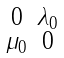Convert formula to latex. <formula><loc_0><loc_0><loc_500><loc_500>\begin{smallmatrix} 0 & \lambda _ { 0 } \\ \mu _ { 0 } & 0 \end{smallmatrix}</formula> 